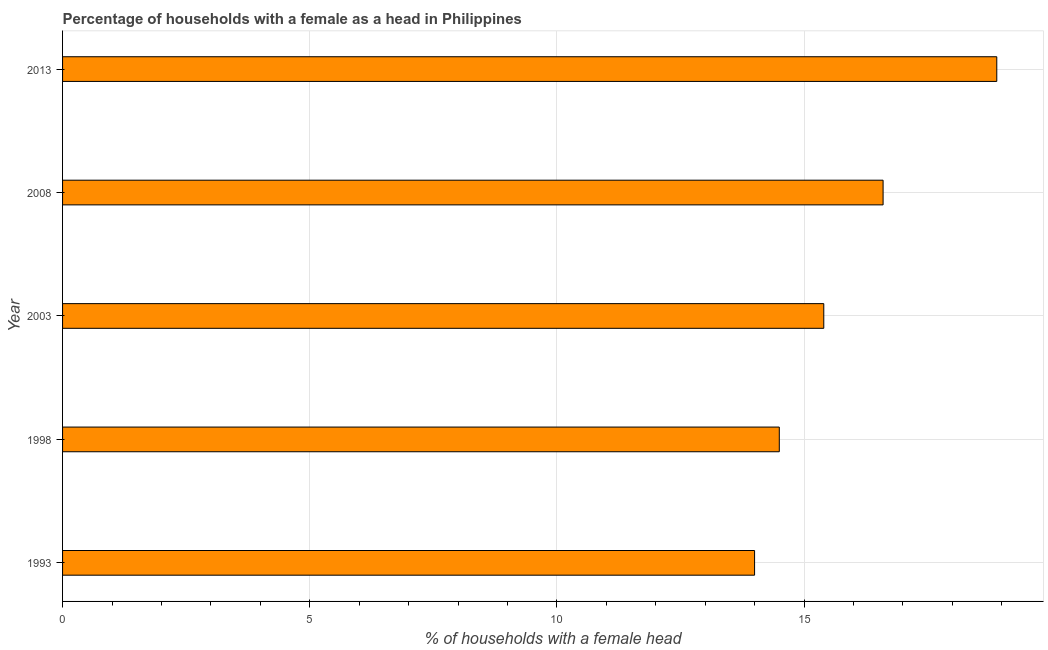Does the graph contain any zero values?
Your response must be concise. No. What is the title of the graph?
Give a very brief answer. Percentage of households with a female as a head in Philippines. What is the label or title of the X-axis?
Your response must be concise. % of households with a female head. Across all years, what is the minimum number of female supervised households?
Offer a terse response. 14. In which year was the number of female supervised households maximum?
Your answer should be very brief. 2013. In which year was the number of female supervised households minimum?
Give a very brief answer. 1993. What is the sum of the number of female supervised households?
Give a very brief answer. 79.4. What is the average number of female supervised households per year?
Make the answer very short. 15.88. What is the median number of female supervised households?
Your answer should be very brief. 15.4. In how many years, is the number of female supervised households greater than 2 %?
Ensure brevity in your answer.  5. Do a majority of the years between 2008 and 2013 (inclusive) have number of female supervised households greater than 16 %?
Provide a short and direct response. Yes. What is the ratio of the number of female supervised households in 2003 to that in 2008?
Your answer should be very brief. 0.93. What is the difference between the highest and the second highest number of female supervised households?
Give a very brief answer. 2.3. Is the sum of the number of female supervised households in 1998 and 2008 greater than the maximum number of female supervised households across all years?
Keep it short and to the point. Yes. Are all the bars in the graph horizontal?
Make the answer very short. Yes. Are the values on the major ticks of X-axis written in scientific E-notation?
Provide a succinct answer. No. What is the % of households with a female head of 1998?
Offer a terse response. 14.5. What is the % of households with a female head in 2013?
Your response must be concise. 18.9. What is the difference between the % of households with a female head in 1993 and 1998?
Ensure brevity in your answer.  -0.5. What is the difference between the % of households with a female head in 1998 and 2003?
Offer a terse response. -0.9. What is the difference between the % of households with a female head in 1998 and 2008?
Offer a terse response. -2.1. What is the ratio of the % of households with a female head in 1993 to that in 2003?
Your response must be concise. 0.91. What is the ratio of the % of households with a female head in 1993 to that in 2008?
Your answer should be compact. 0.84. What is the ratio of the % of households with a female head in 1993 to that in 2013?
Provide a short and direct response. 0.74. What is the ratio of the % of households with a female head in 1998 to that in 2003?
Your response must be concise. 0.94. What is the ratio of the % of households with a female head in 1998 to that in 2008?
Provide a succinct answer. 0.87. What is the ratio of the % of households with a female head in 1998 to that in 2013?
Offer a very short reply. 0.77. What is the ratio of the % of households with a female head in 2003 to that in 2008?
Keep it short and to the point. 0.93. What is the ratio of the % of households with a female head in 2003 to that in 2013?
Keep it short and to the point. 0.81. What is the ratio of the % of households with a female head in 2008 to that in 2013?
Your answer should be compact. 0.88. 